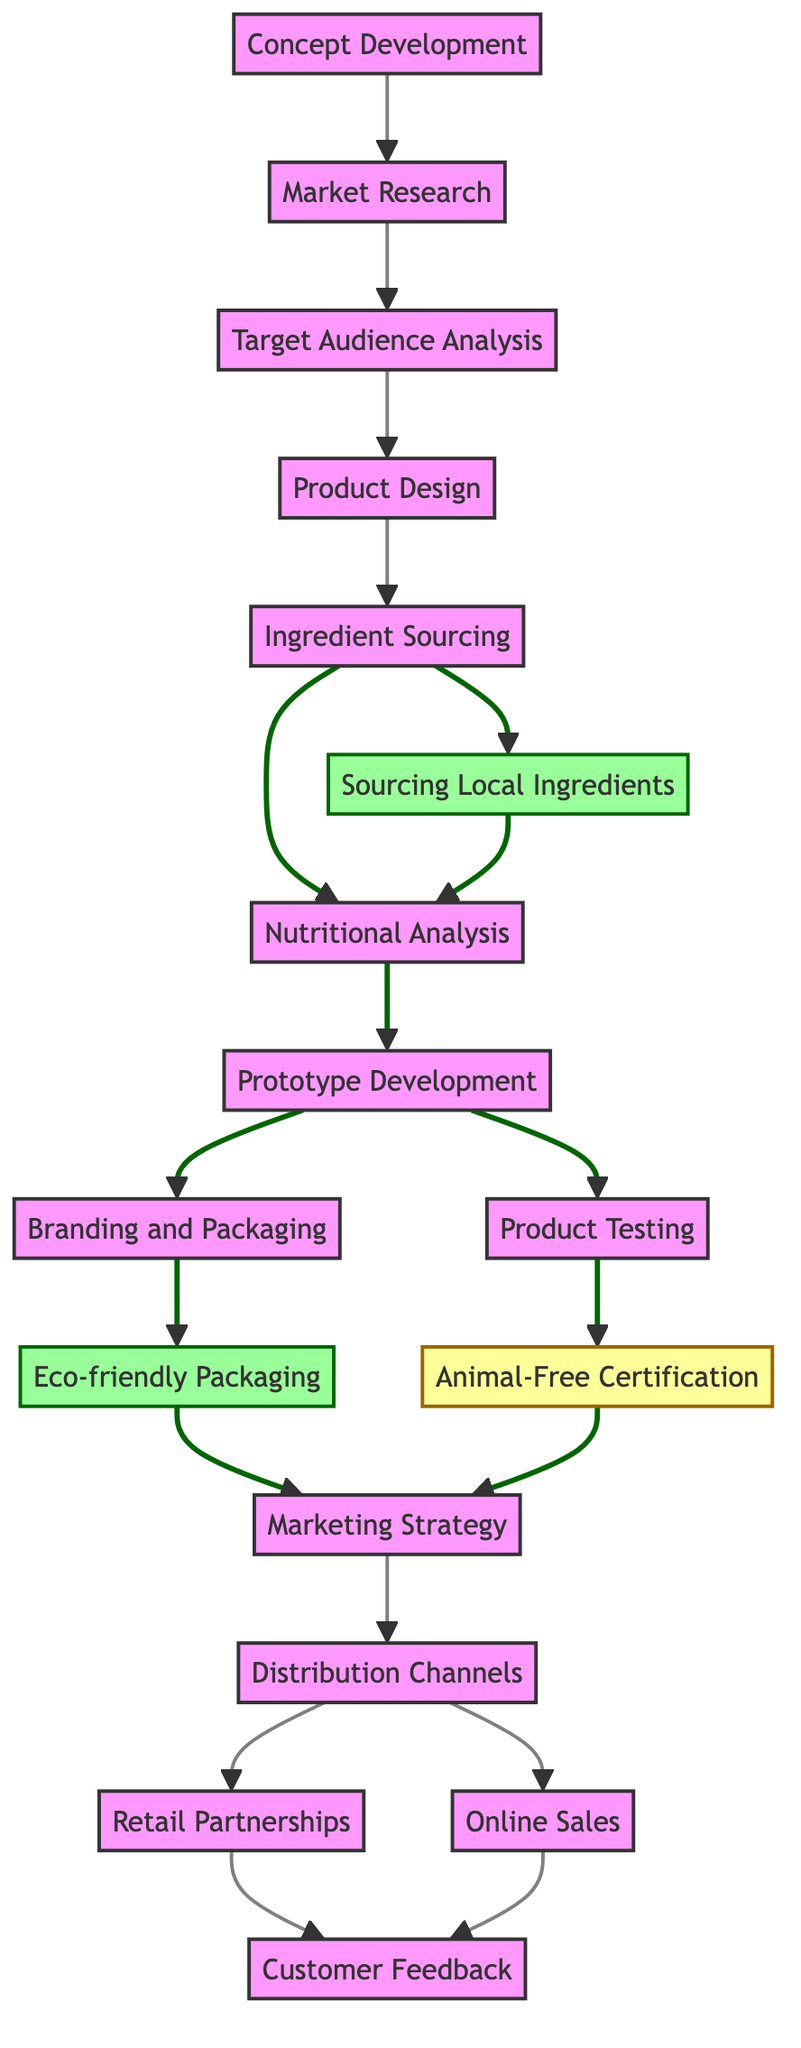What is the first step in the process? The first node in the diagram, which is the starting point, is "Concept Development". This node has no incoming edges, indicating that it is the initial stage of the process.
Answer: Concept Development How many nodes are in the diagram? By counting all the listed nodes in the diagram, we find there are 15 distinct nodes present. This includes all steps from the initial concept development to customer feedback.
Answer: 15 Which node directly follows "Prototype Development"? Examining the edges leading from "Prototype Development", we see two outputs. However, "Product Testing" is the first node that follows it, as it is directly connected by an edge.
Answer: Product Testing What are the two distribution channels mentioned in the diagram? Looking at the edges that emerge from "Distribution Channels", we see two direct connections leading to "Retail Partnerships" and "Online Sales". These represent the two specific distribution channels for the market.
Answer: Retail Partnerships, Online Sales What certification is obtained after product testing? The relationship shows that "Animal-Free Certification" directly follows "Product Testing". This indicates that once product testing is complete, the next step is to obtain the certification affirming it is free of animal products.
Answer: Animal-Free Certification Explain what happens after "Eco-friendly Packaging". Following "Eco-friendly Packaging", we find a single directed edge leading to "Marketing Strategy". This means that once the eco-friendly packaging is established, the focus shifts to developing a marketing strategy.
Answer: Marketing Strategy Which steps involve sourcing ingredients? There are two nodes linked to the ingredient sourcing process: "Sourcing Local Ingredients" and "Nutritional Analysis", both are outcomes of the "Ingredient Sourcing" node, indicating that ingredient sourcing is essential for these processes.
Answer: Sourcing Local Ingredients, Nutritional Analysis How does "Customer Feedback" relate to sales channels? "Customer Feedback" is the output of both "Retail Partnerships" and "Online Sales", which means it is collected from customers regardless of the purchasing method they chose.
Answer: Retail Partnerships, Online Sales What is the last step in the process? The diagram’s flow leads to "Customer Feedback" as the final node, indicating that this step is the endpoint of the directed graph, capturing customer insights after the product reaches the market.
Answer: Customer Feedback 